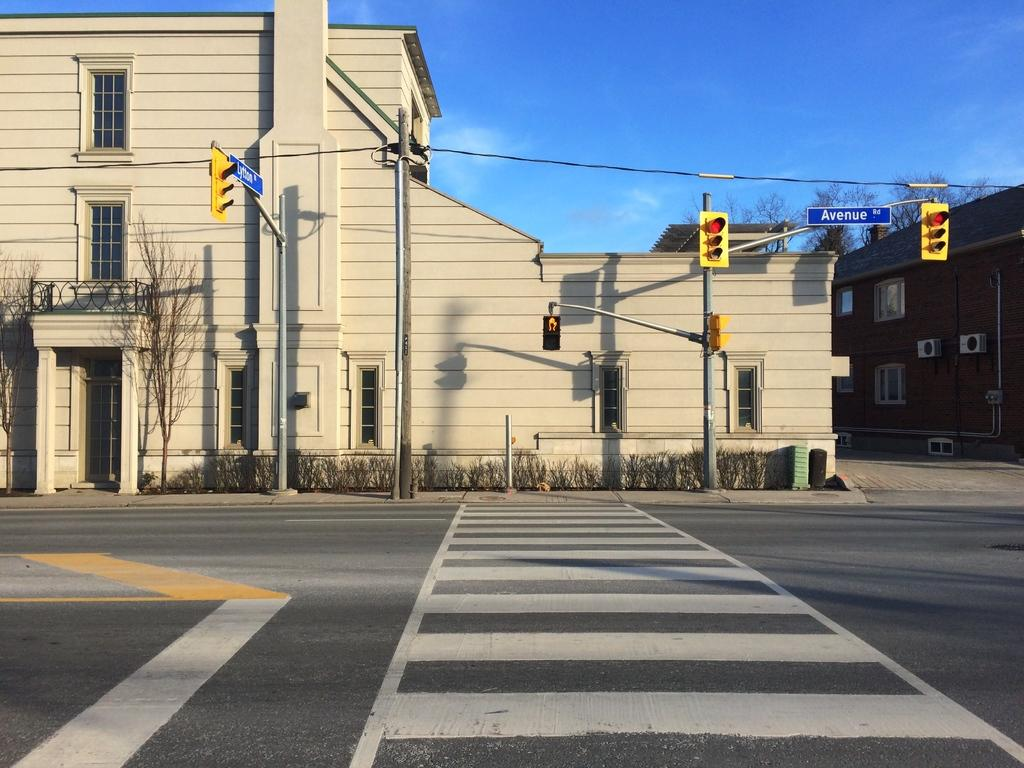Provide a one-sentence caption for the provided image. A road with white crosswalk painted lines and a large tan building and signal lights on the other side of it. 